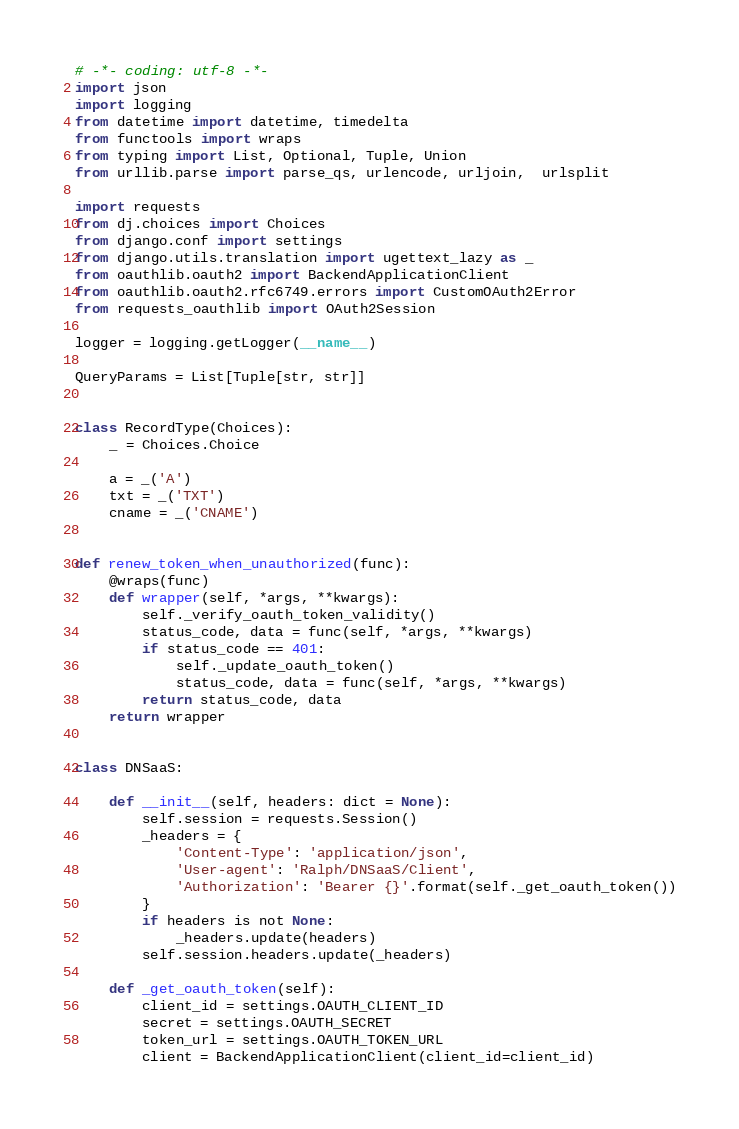<code> <loc_0><loc_0><loc_500><loc_500><_Python_># -*- coding: utf-8 -*-
import json
import logging
from datetime import datetime, timedelta
from functools import wraps
from typing import List, Optional, Tuple, Union
from urllib.parse import parse_qs, urlencode, urljoin,  urlsplit

import requests
from dj.choices import Choices
from django.conf import settings
from django.utils.translation import ugettext_lazy as _
from oauthlib.oauth2 import BackendApplicationClient
from oauthlib.oauth2.rfc6749.errors import CustomOAuth2Error
from requests_oauthlib import OAuth2Session

logger = logging.getLogger(__name__)

QueryParams = List[Tuple[str, str]]


class RecordType(Choices):
    _ = Choices.Choice

    a = _('A')
    txt = _('TXT')
    cname = _('CNAME')


def renew_token_when_unauthorized(func):
    @wraps(func)
    def wrapper(self, *args, **kwargs):
        self._verify_oauth_token_validity()
        status_code, data = func(self, *args, **kwargs)
        if status_code == 401:
            self._update_oauth_token()
            status_code, data = func(self, *args, **kwargs)
        return status_code, data
    return wrapper


class DNSaaS:

    def __init__(self, headers: dict = None):
        self.session = requests.Session()
        _headers = {
            'Content-Type': 'application/json',
            'User-agent': 'Ralph/DNSaaS/Client',
            'Authorization': 'Bearer {}'.format(self._get_oauth_token())
        }
        if headers is not None:
            _headers.update(headers)
        self.session.headers.update(_headers)

    def _get_oauth_token(self):
        client_id = settings.OAUTH_CLIENT_ID
        secret = settings.OAUTH_SECRET
        token_url = settings.OAUTH_TOKEN_URL
        client = BackendApplicationClient(client_id=client_id)</code> 